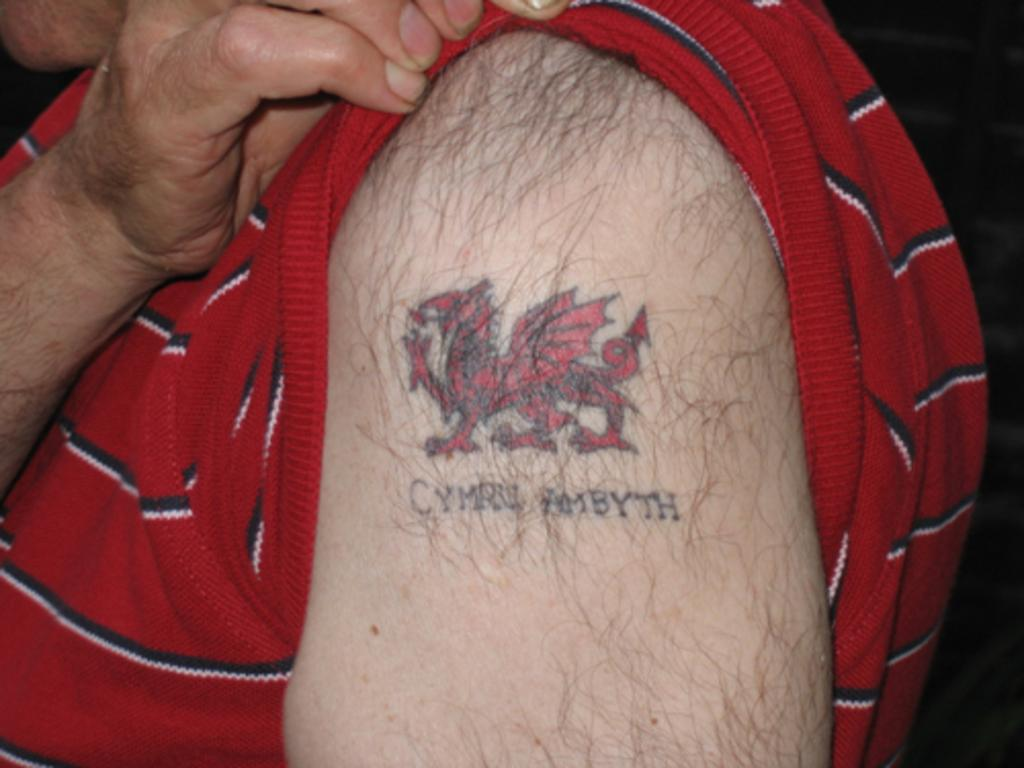Who or what is the main subject in the image? There is a person in the image. What is the person wearing? The person is wearing a red t-shirt. Are there any distinguishing features on the person's body? Yes, the person has a tattoo on their arm. What can be seen on the tattoo? There is some text visible on the person's arm. What type of copper material is being used by the kitty in the image? There is no kitty or copper material present in the image. 